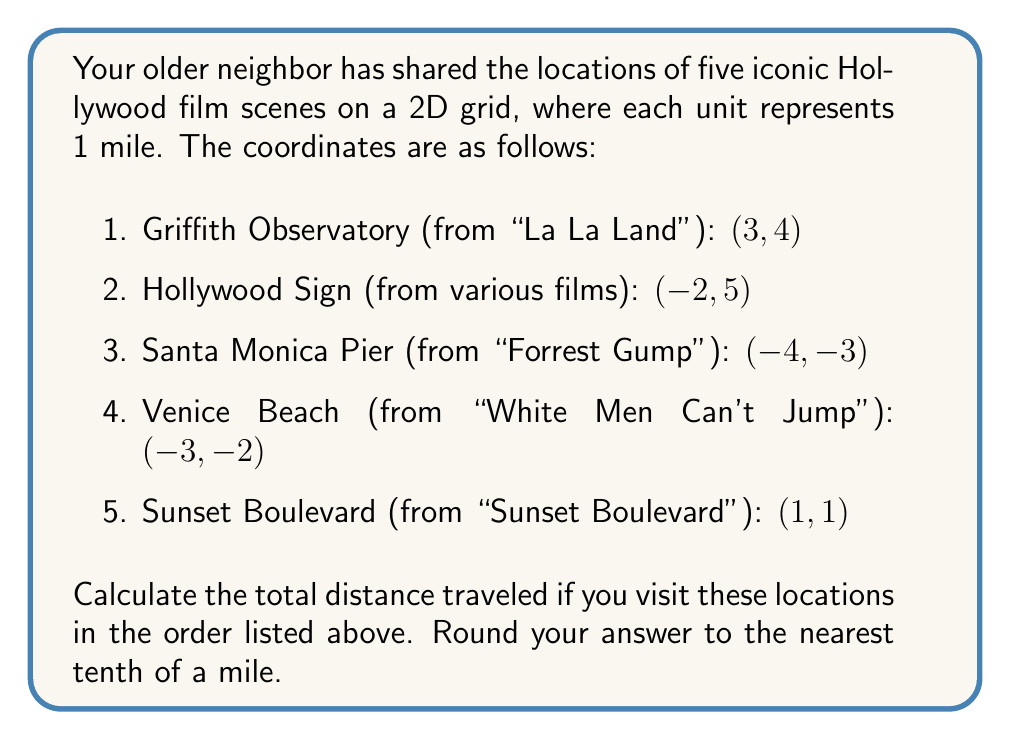Give your solution to this math problem. To solve this problem, we need to calculate the distance between consecutive points and sum them up. We can use the distance formula between two points $(x_1, y_1)$ and $(x_2, y_2)$:

$$ d = \sqrt{(x_2 - x_1)^2 + (y_2 - y_1)^2} $$

Let's calculate the distances:

1. From Griffith Observatory to Hollywood Sign:
   $d_1 = \sqrt{(-2 - 3)^2 + (5 - 4)^2} = \sqrt{(-5)^2 + 1^2} = \sqrt{26} \approx 5.1$ miles

2. From Hollywood Sign to Santa Monica Pier:
   $d_2 = \sqrt{(-4 - (-2))^2 + (-3 - 5)^2} = \sqrt{(-2)^2 + (-8)^2} = \sqrt{68} \approx 8.2$ miles

3. From Santa Monica Pier to Venice Beach:
   $d_3 = \sqrt{(-3 - (-4))^2 + (-2 - (-3))^2} = \sqrt{1^2 + 1^2} = \sqrt{2} \approx 1.4$ miles

4. From Venice Beach to Sunset Boulevard:
   $d_4 = \sqrt{(1 - (-3))^2 + (1 - (-2))^2} = \sqrt{4^2 + 3^2} = \sqrt{25} = 5$ miles

Now, we sum up all these distances:

$$ \text{Total distance} = d_1 + d_2 + d_3 + d_4 $$
$$ \approx 5.1 + 8.2 + 1.4 + 5 = 19.7 \text{ miles} $$

Rounding to the nearest tenth, we get 19.7 miles.
Answer: 19.7 miles 